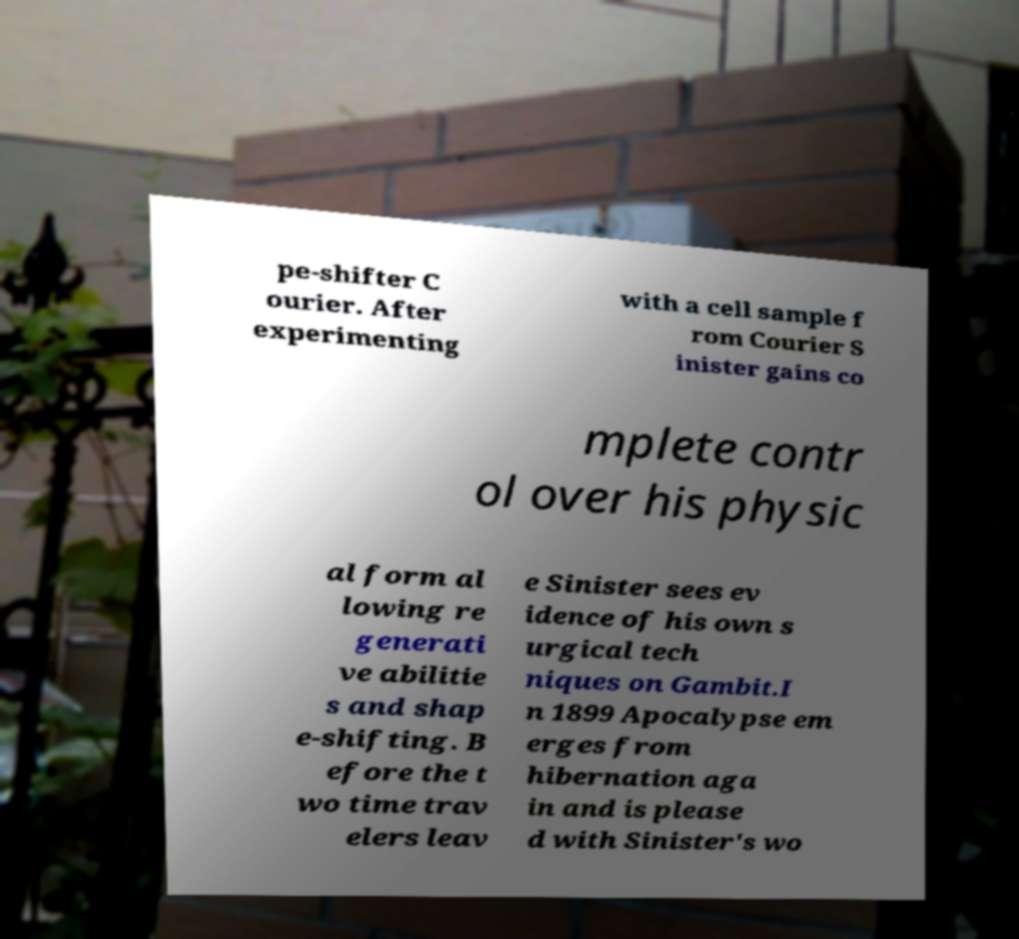Can you read and provide the text displayed in the image?This photo seems to have some interesting text. Can you extract and type it out for me? pe-shifter C ourier. After experimenting with a cell sample f rom Courier S inister gains co mplete contr ol over his physic al form al lowing re generati ve abilitie s and shap e-shifting. B efore the t wo time trav elers leav e Sinister sees ev idence of his own s urgical tech niques on Gambit.I n 1899 Apocalypse em erges from hibernation aga in and is please d with Sinister's wo 